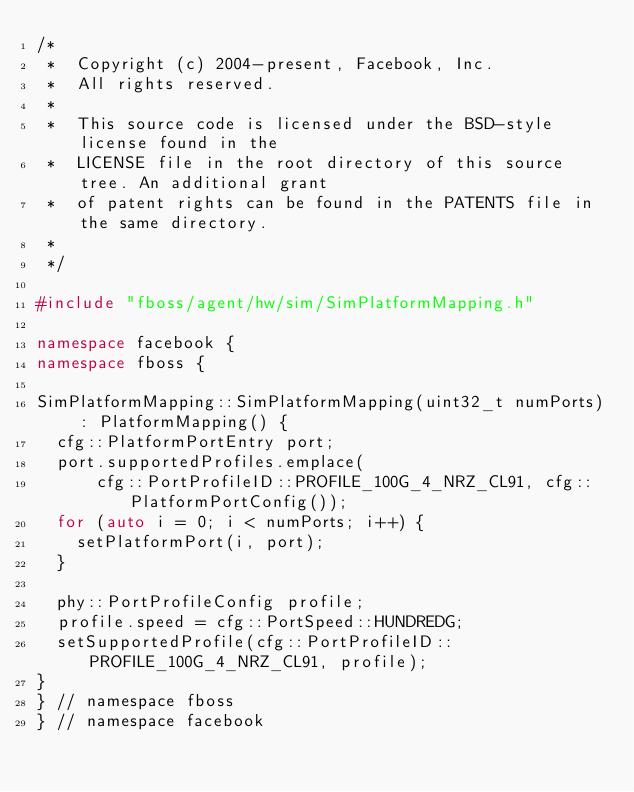<code> <loc_0><loc_0><loc_500><loc_500><_C++_>/*
 *  Copyright (c) 2004-present, Facebook, Inc.
 *  All rights reserved.
 *
 *  This source code is licensed under the BSD-style license found in the
 *  LICENSE file in the root directory of this source tree. An additional grant
 *  of patent rights can be found in the PATENTS file in the same directory.
 *
 */

#include "fboss/agent/hw/sim/SimPlatformMapping.h"

namespace facebook {
namespace fboss {

SimPlatformMapping::SimPlatformMapping(uint32_t numPorts) : PlatformMapping() {
  cfg::PlatformPortEntry port;
  port.supportedProfiles.emplace(
      cfg::PortProfileID::PROFILE_100G_4_NRZ_CL91, cfg::PlatformPortConfig());
  for (auto i = 0; i < numPorts; i++) {
    setPlatformPort(i, port);
  }

  phy::PortProfileConfig profile;
  profile.speed = cfg::PortSpeed::HUNDREDG;
  setSupportedProfile(cfg::PortProfileID::PROFILE_100G_4_NRZ_CL91, profile);
}
} // namespace fboss
} // namespace facebook
</code> 